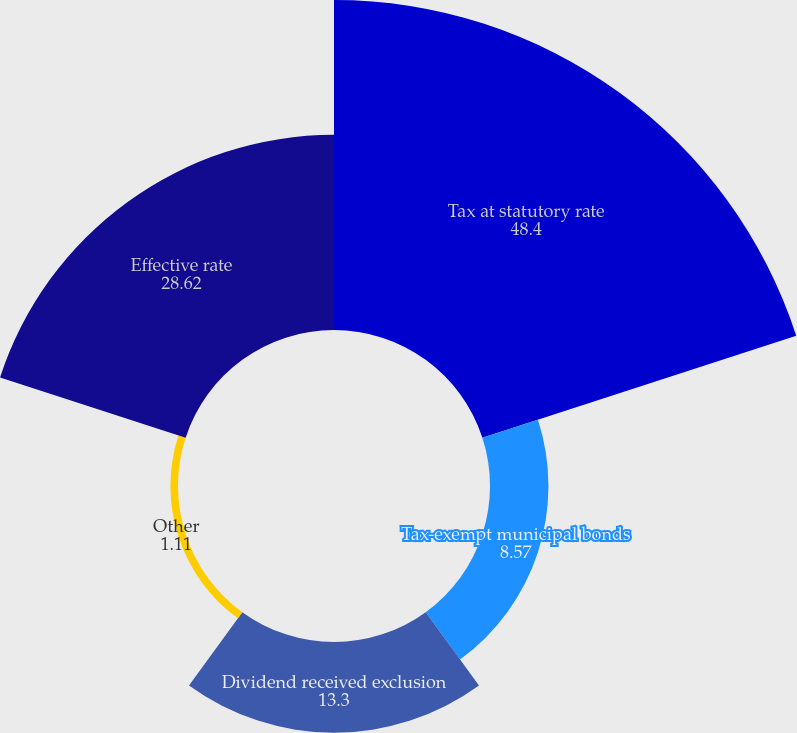<chart> <loc_0><loc_0><loc_500><loc_500><pie_chart><fcel>Tax at statutory rate<fcel>Tax-exempt municipal bonds<fcel>Dividend received exclusion<fcel>Other<fcel>Effective rate<nl><fcel>48.4%<fcel>8.57%<fcel>13.3%<fcel>1.11%<fcel>28.62%<nl></chart> 